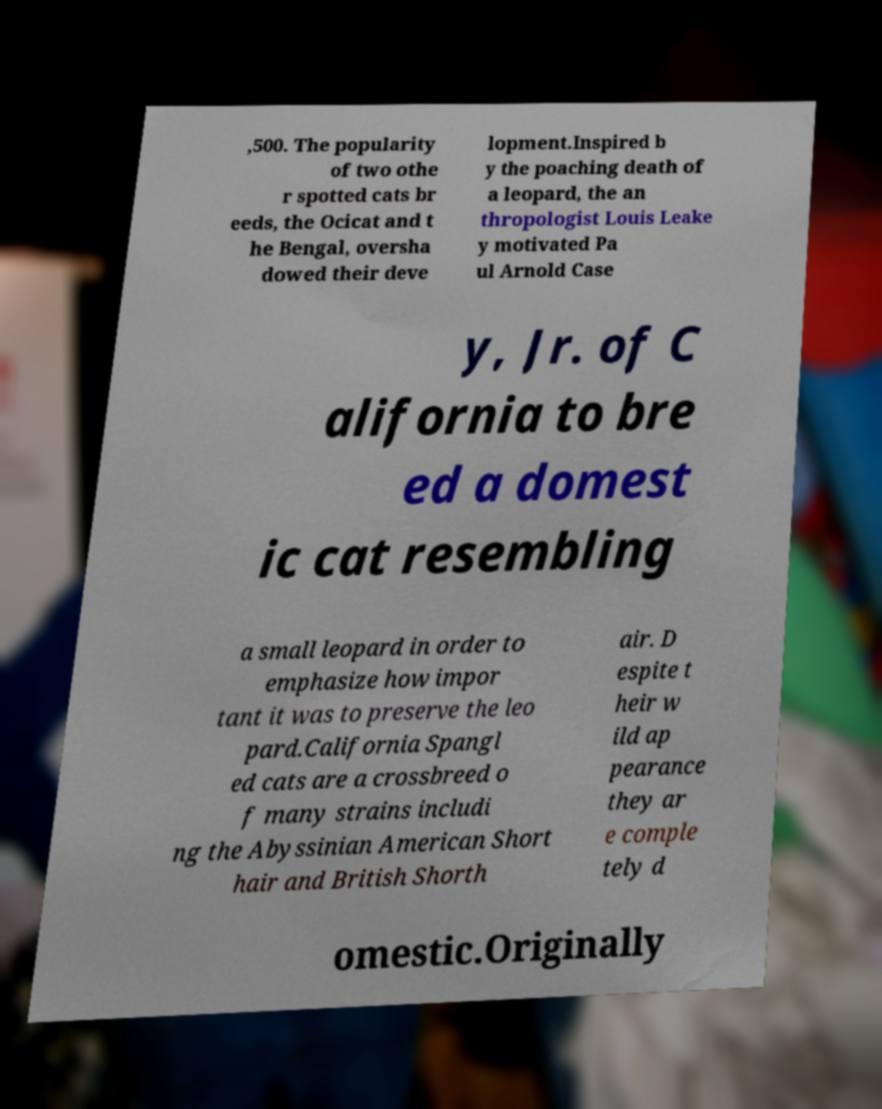There's text embedded in this image that I need extracted. Can you transcribe it verbatim? ,500. The popularity of two othe r spotted cats br eeds, the Ocicat and t he Bengal, oversha dowed their deve lopment.Inspired b y the poaching death of a leopard, the an thropologist Louis Leake y motivated Pa ul Arnold Case y, Jr. of C alifornia to bre ed a domest ic cat resembling a small leopard in order to emphasize how impor tant it was to preserve the leo pard.California Spangl ed cats are a crossbreed o f many strains includi ng the Abyssinian American Short hair and British Shorth air. D espite t heir w ild ap pearance they ar e comple tely d omestic.Originally 